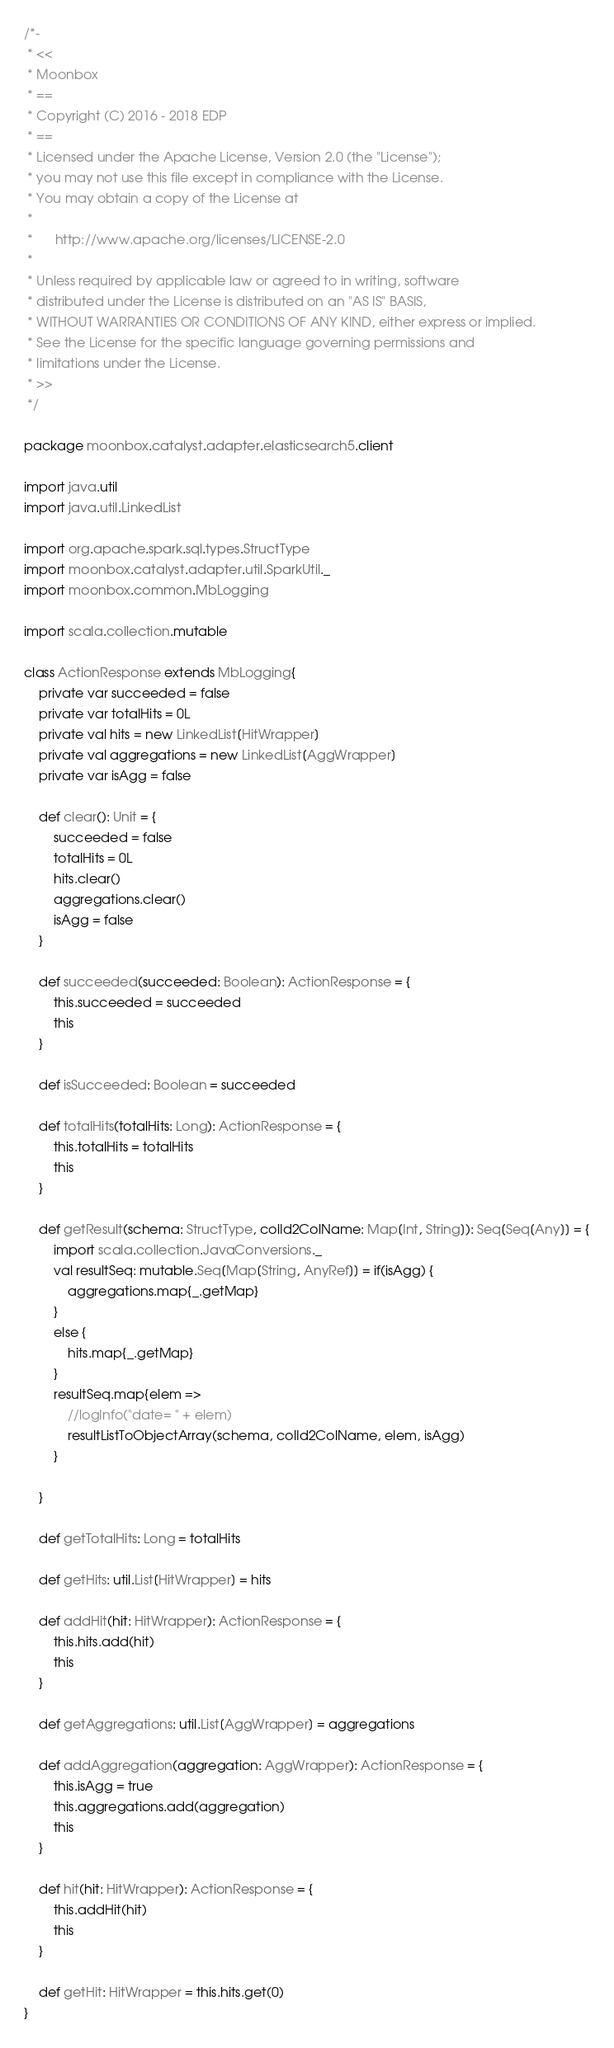<code> <loc_0><loc_0><loc_500><loc_500><_Scala_>/*-
 * <<
 * Moonbox
 * ==
 * Copyright (C) 2016 - 2018 EDP
 * ==
 * Licensed under the Apache License, Version 2.0 (the "License");
 * you may not use this file except in compliance with the License.
 * You may obtain a copy of the License at
 * 
 *      http://www.apache.org/licenses/LICENSE-2.0
 * 
 * Unless required by applicable law or agreed to in writing, software
 * distributed under the License is distributed on an "AS IS" BASIS,
 * WITHOUT WARRANTIES OR CONDITIONS OF ANY KIND, either express or implied.
 * See the License for the specific language governing permissions and
 * limitations under the License.
 * >>
 */

package moonbox.catalyst.adapter.elasticsearch5.client

import java.util
import java.util.LinkedList

import org.apache.spark.sql.types.StructType
import moonbox.catalyst.adapter.util.SparkUtil._
import moonbox.common.MbLogging

import scala.collection.mutable

class ActionResponse extends MbLogging{
    private var succeeded = false
    private var totalHits = 0L
    private val hits = new LinkedList[HitWrapper]
    private val aggregations = new LinkedList[AggWrapper]
    private var isAgg = false

    def clear(): Unit = {
        succeeded = false
        totalHits = 0L
        hits.clear()
        aggregations.clear()
        isAgg = false
    }

    def succeeded(succeeded: Boolean): ActionResponse = {
        this.succeeded = succeeded
        this
    }

    def isSucceeded: Boolean = succeeded

    def totalHits(totalHits: Long): ActionResponse = {
        this.totalHits = totalHits
        this
    }

    def getResult(schema: StructType, colId2ColName: Map[Int, String]): Seq[Seq[Any]] = {
        import scala.collection.JavaConversions._
        val resultSeq: mutable.Seq[Map[String, AnyRef]] = if(isAgg) {
            aggregations.map{_.getMap}
        }
        else {
            hits.map{_.getMap}
        }
        resultSeq.map{elem =>
            //logInfo("date= " + elem)
            resultListToObjectArray(schema, colId2ColName, elem, isAgg)
        }

    }

    def getTotalHits: Long = totalHits

    def getHits: util.List[HitWrapper] = hits

    def addHit(hit: HitWrapper): ActionResponse = {
        this.hits.add(hit)
        this
    }

    def getAggregations: util.List[AggWrapper] = aggregations

    def addAggregation(aggregation: AggWrapper): ActionResponse = {
        this.isAgg = true
        this.aggregations.add(aggregation)
        this
    }

    def hit(hit: HitWrapper): ActionResponse = {
        this.addHit(hit)
        this
    }

    def getHit: HitWrapper = this.hits.get(0)
}
</code> 